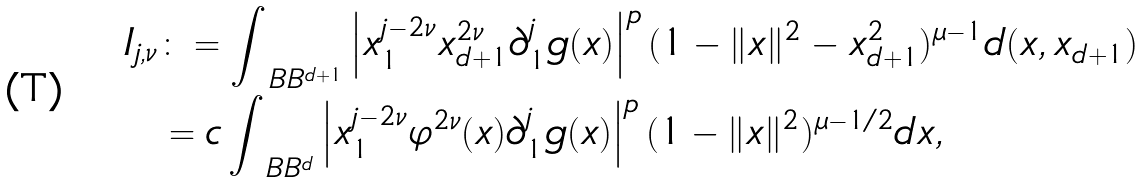<formula> <loc_0><loc_0><loc_500><loc_500>I _ { j , \nu } & \colon = \int _ { \ B B ^ { d + 1 } } \left | x _ { 1 } ^ { j - 2 \nu } x _ { d + 1 } ^ { 2 \nu } \partial _ { 1 } ^ { j } g ( x ) \right | ^ { p } ( 1 - \| x \| ^ { 2 } - x _ { d + 1 } ^ { 2 } ) ^ { \mu - 1 } d ( x , x _ { d + 1 } ) \\ & = c \int _ { \ B B ^ { d } } \left | x _ { 1 } ^ { j - 2 \nu } \varphi ^ { 2 \nu } ( x ) \partial _ { 1 } ^ { j } g ( x ) \right | ^ { p } ( 1 - \| x \| ^ { 2 } ) ^ { \mu - 1 / 2 } d x ,</formula> 